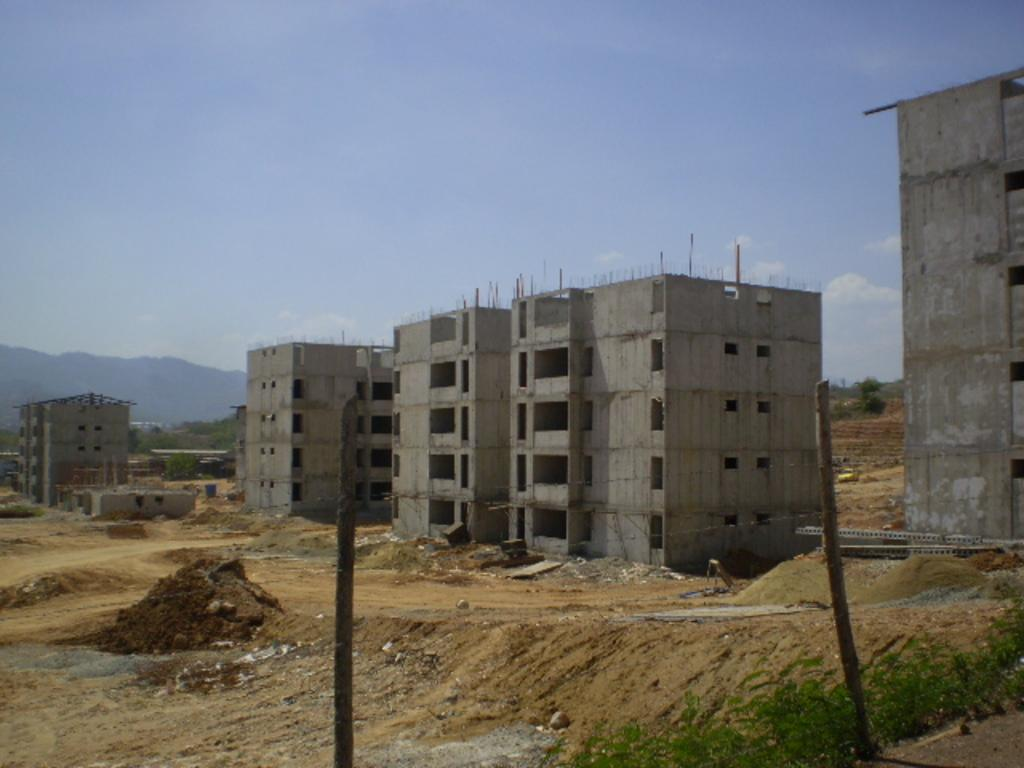What type of terrain is visible in the image? There is a land visible in the image. What structures are present on the land? There are buildings on the land. What natural feature can be seen in the background of the image? There is a mountain in the background of the image. What else is visible in the background of the image? The sky is visible in the background of the image. What type of alarm can be heard going off in the image? There is no alarm present in the image, and therefore no sound can be heard. 